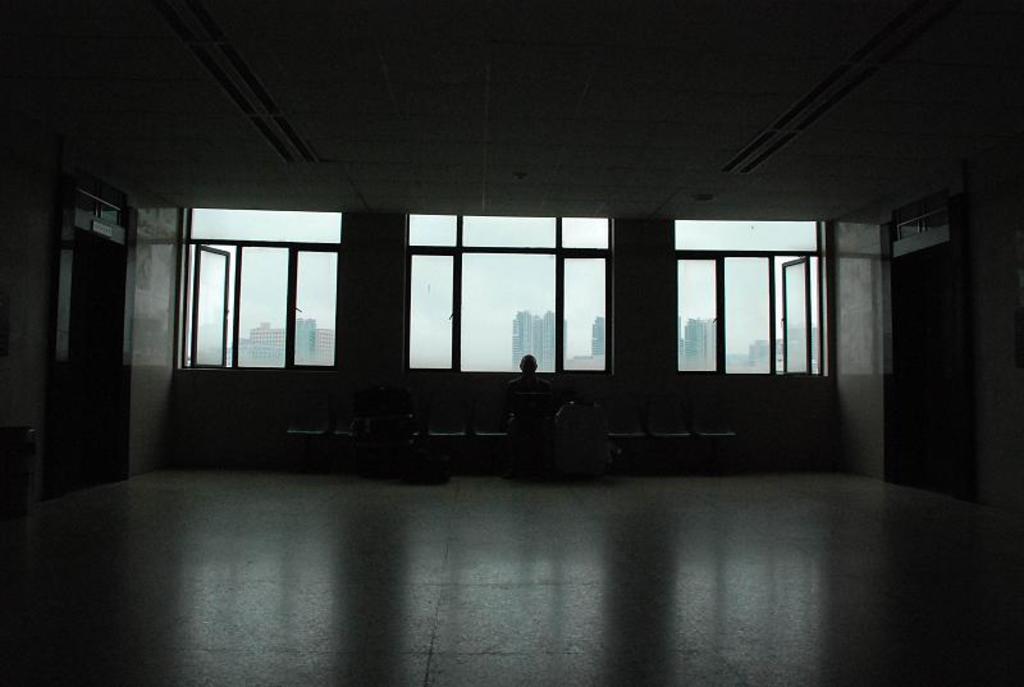Can you describe this image briefly? In this picture there is a person sitting in chair and there are few luggages and doors on either sides of him and there are glass windows behind him and there are buildings in the background. 